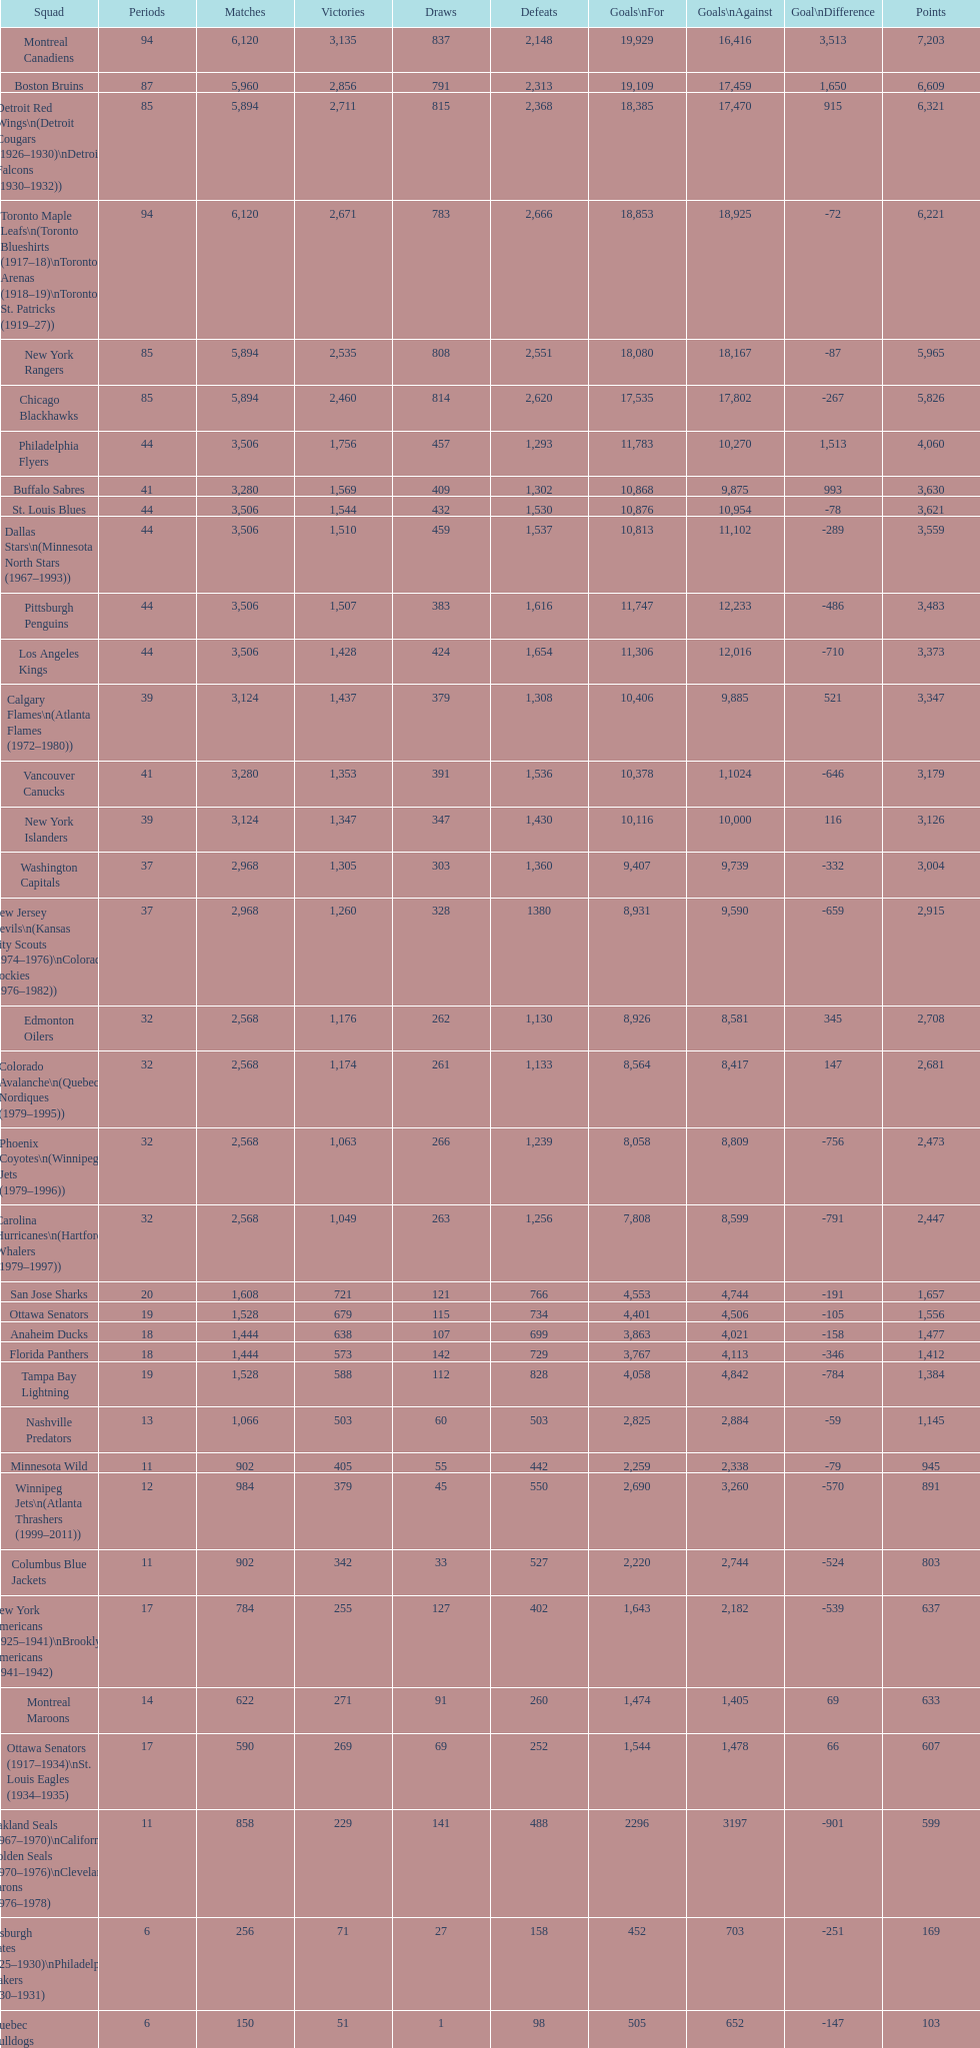How many teams have won more than 1,500 games? 11. 